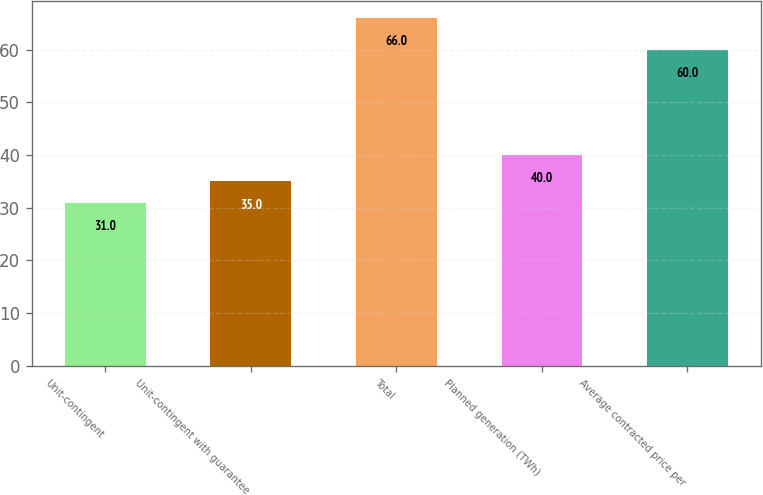Convert chart. <chart><loc_0><loc_0><loc_500><loc_500><bar_chart><fcel>Unit-contingent<fcel>Unit-contingent with guarantee<fcel>Total<fcel>Planned generation (TWh)<fcel>Average contracted price per<nl><fcel>31<fcel>35<fcel>66<fcel>40<fcel>60<nl></chart> 